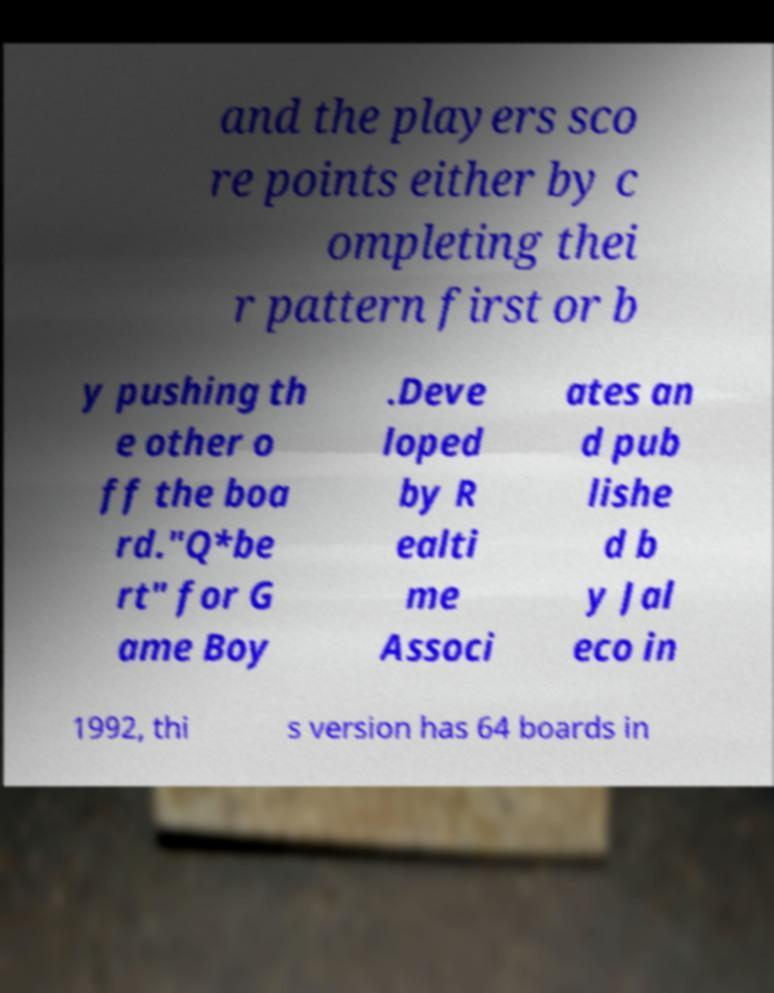Please read and relay the text visible in this image. What does it say? and the players sco re points either by c ompleting thei r pattern first or b y pushing th e other o ff the boa rd."Q*be rt" for G ame Boy .Deve loped by R ealti me Associ ates an d pub lishe d b y Jal eco in 1992, thi s version has 64 boards in 